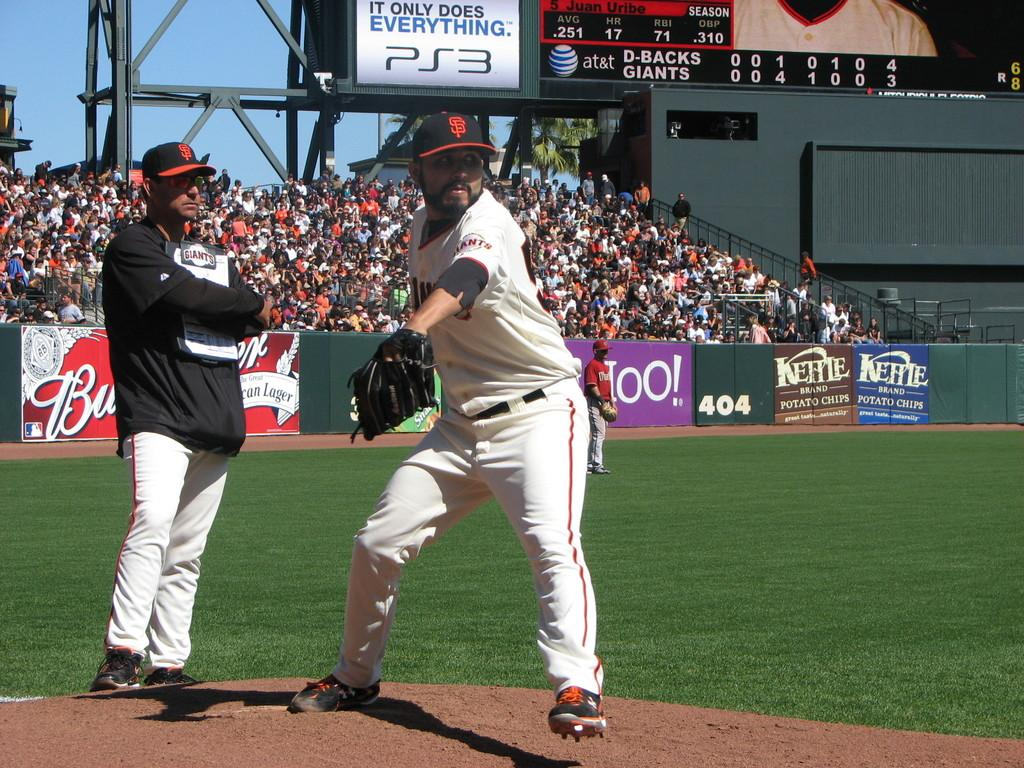<image>
Give a short and clear explanation of the subsequent image. Baseball player in front of an advertisement for the PS3. 